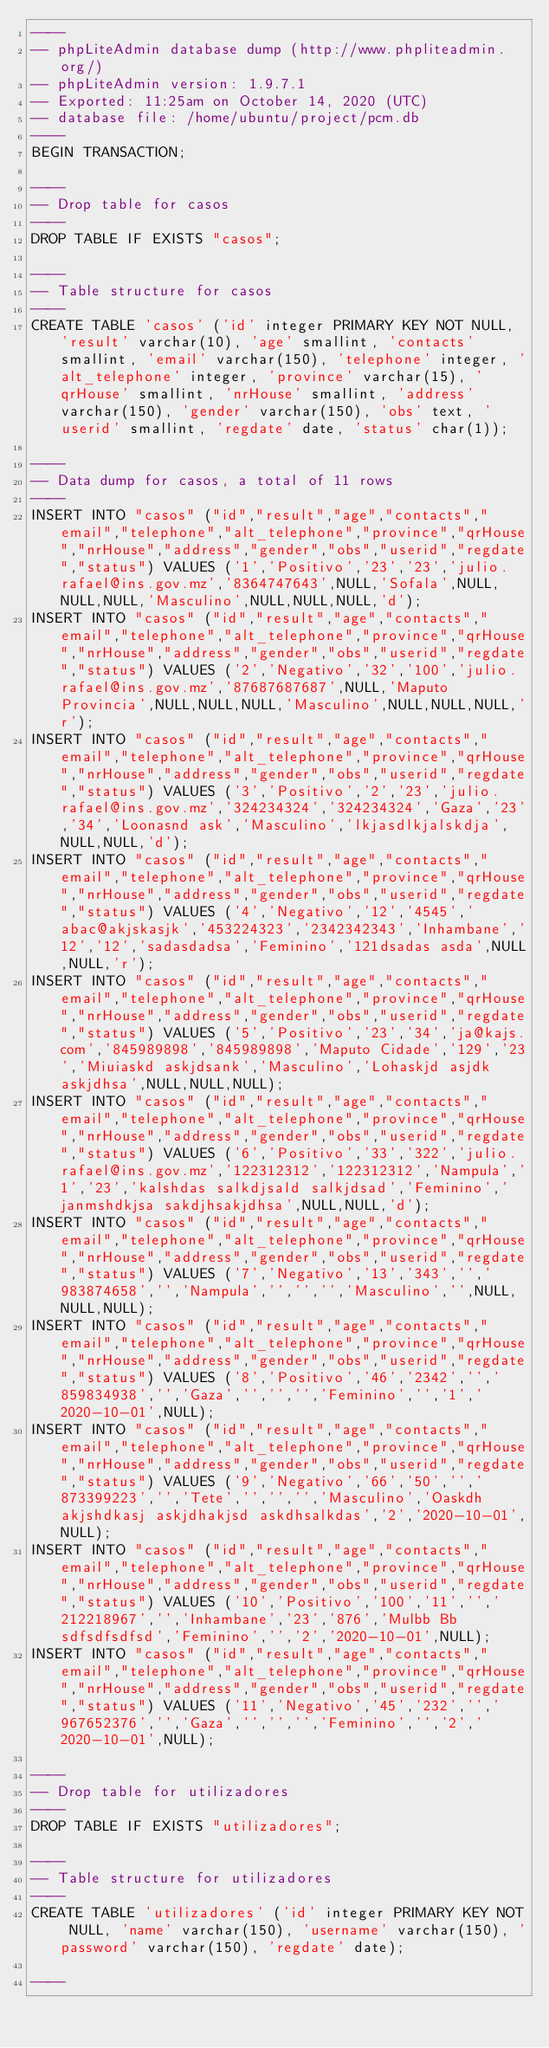<code> <loc_0><loc_0><loc_500><loc_500><_SQL_>----
-- phpLiteAdmin database dump (http://www.phpliteadmin.org/)
-- phpLiteAdmin version: 1.9.7.1
-- Exported: 11:25am on October 14, 2020 (UTC)
-- database file: /home/ubuntu/project/pcm.db
----
BEGIN TRANSACTION;

----
-- Drop table for casos
----
DROP TABLE IF EXISTS "casos";

----
-- Table structure for casos
----
CREATE TABLE 'casos' ('id' integer PRIMARY KEY NOT NULL, 'result' varchar(10), 'age' smallint, 'contacts' smallint, 'email' varchar(150), 'telephone' integer, 'alt_telephone' integer, 'province' varchar(15), 'qrHouse' smallint, 'nrHouse' smallint, 'address' varchar(150), 'gender' varchar(150), 'obs' text, 'userid' smallint, 'regdate' date, 'status' char(1));

----
-- Data dump for casos, a total of 11 rows
----
INSERT INTO "casos" ("id","result","age","contacts","email","telephone","alt_telephone","province","qrHouse","nrHouse","address","gender","obs","userid","regdate","status") VALUES ('1','Positivo','23','23','julio.rafael@ins.gov.mz','8364747643',NULL,'Sofala',NULL,NULL,NULL,'Masculino',NULL,NULL,NULL,'d');
INSERT INTO "casos" ("id","result","age","contacts","email","telephone","alt_telephone","province","qrHouse","nrHouse","address","gender","obs","userid","regdate","status") VALUES ('2','Negativo','32','100','julio.rafael@ins.gov.mz','87687687687',NULL,'Maputo Provincia',NULL,NULL,NULL,'Masculino',NULL,NULL,NULL,'r');
INSERT INTO "casos" ("id","result","age","contacts","email","telephone","alt_telephone","province","qrHouse","nrHouse","address","gender","obs","userid","regdate","status") VALUES ('3','Positivo','2','23','julio.rafael@ins.gov.mz','324234324','324234324','Gaza','23','34','Loonasnd ask','Masculino','lkjasdlkjalskdja',NULL,NULL,'d');
INSERT INTO "casos" ("id","result","age","contacts","email","telephone","alt_telephone","province","qrHouse","nrHouse","address","gender","obs","userid","regdate","status") VALUES ('4','Negativo','12','4545','abac@akjskasjk','453224323','2342342343','Inhambane','12','12','sadasdadsa','Feminino','121dsadas asda',NULL,NULL,'r');
INSERT INTO "casos" ("id","result","age","contacts","email","telephone","alt_telephone","province","qrHouse","nrHouse","address","gender","obs","userid","regdate","status") VALUES ('5','Positivo','23','34','ja@kajs.com','845989898','845989898','Maputo Cidade','129','23','Miuiaskd askjdsank','Masculino','Lohaskjd asjdk askjdhsa',NULL,NULL,NULL);
INSERT INTO "casos" ("id","result","age","contacts","email","telephone","alt_telephone","province","qrHouse","nrHouse","address","gender","obs","userid","regdate","status") VALUES ('6','Positivo','33','322','julio.rafael@ins.gov.mz','122312312','122312312','Nampula','1','23','kalshdas salkdjsald salkjdsad','Feminino','janmshdkjsa sakdjhsakjdhsa',NULL,NULL,'d');
INSERT INTO "casos" ("id","result","age","contacts","email","telephone","alt_telephone","province","qrHouse","nrHouse","address","gender","obs","userid","regdate","status") VALUES ('7','Negativo','13','343','','983874658','','Nampula','','','','Masculino','',NULL,NULL,NULL);
INSERT INTO "casos" ("id","result","age","contacts","email","telephone","alt_telephone","province","qrHouse","nrHouse","address","gender","obs","userid","regdate","status") VALUES ('8','Positivo','46','2342','','859834938','','Gaza','','','','Feminino','','1','2020-10-01',NULL);
INSERT INTO "casos" ("id","result","age","contacts","email","telephone","alt_telephone","province","qrHouse","nrHouse","address","gender","obs","userid","regdate","status") VALUES ('9','Negativo','66','50','','873399223','','Tete','','','','Masculino','Oaskdh akjshdkasj askjdhakjsd askdhsalkdas','2','2020-10-01',NULL);
INSERT INTO "casos" ("id","result","age","contacts","email","telephone","alt_telephone","province","qrHouse","nrHouse","address","gender","obs","userid","regdate","status") VALUES ('10','Positivo','100','11','','212218967','','Inhambane','23','876','Mulbb Bb sdfsdfsdfsd','Feminino','','2','2020-10-01',NULL);
INSERT INTO "casos" ("id","result","age","contacts","email","telephone","alt_telephone","province","qrHouse","nrHouse","address","gender","obs","userid","regdate","status") VALUES ('11','Negativo','45','232','','967652376','','Gaza','','','','Feminino','','2','2020-10-01',NULL);

----
-- Drop table for utilizadores
----
DROP TABLE IF EXISTS "utilizadores";

----
-- Table structure for utilizadores
----
CREATE TABLE 'utilizadores' ('id' integer PRIMARY KEY NOT NULL, 'name' varchar(150), 'username' varchar(150), 'password' varchar(150), 'regdate' date);

----</code> 